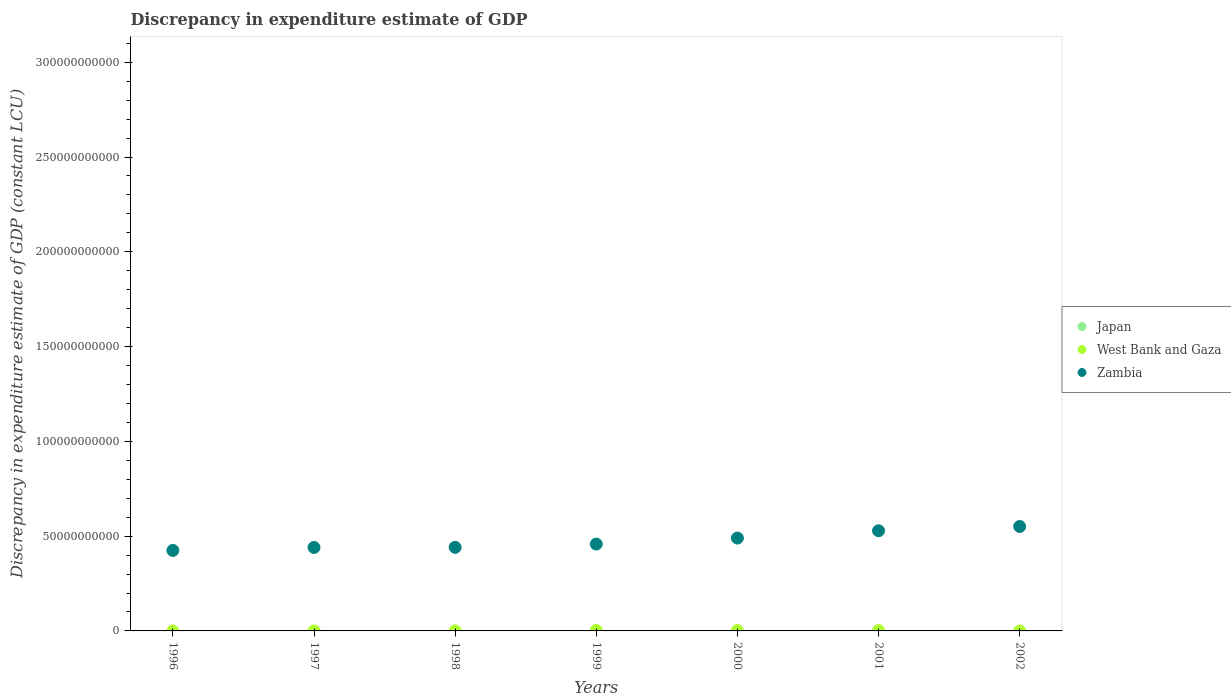How many different coloured dotlines are there?
Your answer should be compact. 2. Is the number of dotlines equal to the number of legend labels?
Your answer should be compact. No. Across all years, what is the maximum discrepancy in expenditure estimate of GDP in West Bank and Gaza?
Give a very brief answer. 2.63e+08. In which year was the discrepancy in expenditure estimate of GDP in Zambia maximum?
Give a very brief answer. 2002. What is the difference between the discrepancy in expenditure estimate of GDP in Zambia in 1999 and that in 2001?
Your answer should be compact. -7.03e+09. What is the difference between the discrepancy in expenditure estimate of GDP in Japan in 1997 and the discrepancy in expenditure estimate of GDP in Zambia in 2000?
Provide a succinct answer. -4.90e+1. What is the average discrepancy in expenditure estimate of GDP in Zambia per year?
Give a very brief answer. 4.76e+1. In the year 1999, what is the difference between the discrepancy in expenditure estimate of GDP in West Bank and Gaza and discrepancy in expenditure estimate of GDP in Zambia?
Make the answer very short. -4.55e+1. What is the ratio of the discrepancy in expenditure estimate of GDP in Zambia in 1997 to that in 1999?
Your answer should be compact. 0.96. Is the difference between the discrepancy in expenditure estimate of GDP in West Bank and Gaza in 1998 and 1999 greater than the difference between the discrepancy in expenditure estimate of GDP in Zambia in 1998 and 1999?
Keep it short and to the point. Yes. What is the difference between the highest and the second highest discrepancy in expenditure estimate of GDP in West Bank and Gaza?
Your answer should be compact. 3.36e+07. What is the difference between the highest and the lowest discrepancy in expenditure estimate of GDP in West Bank and Gaza?
Give a very brief answer. 2.63e+08. In how many years, is the discrepancy in expenditure estimate of GDP in Zambia greater than the average discrepancy in expenditure estimate of GDP in Zambia taken over all years?
Provide a short and direct response. 3. Is it the case that in every year, the sum of the discrepancy in expenditure estimate of GDP in Zambia and discrepancy in expenditure estimate of GDP in West Bank and Gaza  is greater than the discrepancy in expenditure estimate of GDP in Japan?
Keep it short and to the point. Yes. How many dotlines are there?
Make the answer very short. 2. How many years are there in the graph?
Your answer should be compact. 7. What is the difference between two consecutive major ticks on the Y-axis?
Provide a short and direct response. 5.00e+1. Are the values on the major ticks of Y-axis written in scientific E-notation?
Make the answer very short. No. Does the graph contain any zero values?
Offer a very short reply. Yes. How are the legend labels stacked?
Your answer should be very brief. Vertical. What is the title of the graph?
Provide a short and direct response. Discrepancy in expenditure estimate of GDP. What is the label or title of the Y-axis?
Your answer should be compact. Discrepancy in expenditure estimate of GDP (constant LCU). What is the Discrepancy in expenditure estimate of GDP (constant LCU) of Japan in 1996?
Offer a terse response. 0. What is the Discrepancy in expenditure estimate of GDP (constant LCU) of Zambia in 1996?
Your answer should be very brief. 4.25e+1. What is the Discrepancy in expenditure estimate of GDP (constant LCU) in Japan in 1997?
Keep it short and to the point. 0. What is the Discrepancy in expenditure estimate of GDP (constant LCU) in Zambia in 1997?
Offer a terse response. 4.40e+1. What is the Discrepancy in expenditure estimate of GDP (constant LCU) of West Bank and Gaza in 1998?
Your response must be concise. 6.65e+07. What is the Discrepancy in expenditure estimate of GDP (constant LCU) of Zambia in 1998?
Make the answer very short. 4.41e+1. What is the Discrepancy in expenditure estimate of GDP (constant LCU) of Japan in 1999?
Your answer should be compact. 0. What is the Discrepancy in expenditure estimate of GDP (constant LCU) of West Bank and Gaza in 1999?
Give a very brief answer. 2.63e+08. What is the Discrepancy in expenditure estimate of GDP (constant LCU) in Zambia in 1999?
Offer a terse response. 4.58e+1. What is the Discrepancy in expenditure estimate of GDP (constant LCU) of Japan in 2000?
Make the answer very short. 0. What is the Discrepancy in expenditure estimate of GDP (constant LCU) in West Bank and Gaza in 2000?
Ensure brevity in your answer.  2.30e+08. What is the Discrepancy in expenditure estimate of GDP (constant LCU) of Zambia in 2000?
Offer a terse response. 4.90e+1. What is the Discrepancy in expenditure estimate of GDP (constant LCU) in West Bank and Gaza in 2001?
Keep it short and to the point. 2.24e+08. What is the Discrepancy in expenditure estimate of GDP (constant LCU) of Zambia in 2001?
Offer a terse response. 5.28e+1. What is the Discrepancy in expenditure estimate of GDP (constant LCU) of Japan in 2002?
Give a very brief answer. 0. What is the Discrepancy in expenditure estimate of GDP (constant LCU) in West Bank and Gaza in 2002?
Give a very brief answer. 0. What is the Discrepancy in expenditure estimate of GDP (constant LCU) in Zambia in 2002?
Ensure brevity in your answer.  5.51e+1. Across all years, what is the maximum Discrepancy in expenditure estimate of GDP (constant LCU) of West Bank and Gaza?
Give a very brief answer. 2.63e+08. Across all years, what is the maximum Discrepancy in expenditure estimate of GDP (constant LCU) of Zambia?
Offer a very short reply. 5.51e+1. Across all years, what is the minimum Discrepancy in expenditure estimate of GDP (constant LCU) in West Bank and Gaza?
Keep it short and to the point. 0. Across all years, what is the minimum Discrepancy in expenditure estimate of GDP (constant LCU) in Zambia?
Offer a terse response. 4.25e+1. What is the total Discrepancy in expenditure estimate of GDP (constant LCU) of West Bank and Gaza in the graph?
Keep it short and to the point. 7.84e+08. What is the total Discrepancy in expenditure estimate of GDP (constant LCU) in Zambia in the graph?
Keep it short and to the point. 3.33e+11. What is the difference between the Discrepancy in expenditure estimate of GDP (constant LCU) in Zambia in 1996 and that in 1997?
Provide a short and direct response. -1.57e+09. What is the difference between the Discrepancy in expenditure estimate of GDP (constant LCU) in Zambia in 1996 and that in 1998?
Keep it short and to the point. -1.64e+09. What is the difference between the Discrepancy in expenditure estimate of GDP (constant LCU) in Zambia in 1996 and that in 1999?
Your response must be concise. -3.36e+09. What is the difference between the Discrepancy in expenditure estimate of GDP (constant LCU) in Zambia in 1996 and that in 2000?
Make the answer very short. -6.53e+09. What is the difference between the Discrepancy in expenditure estimate of GDP (constant LCU) in Zambia in 1996 and that in 2001?
Give a very brief answer. -1.04e+1. What is the difference between the Discrepancy in expenditure estimate of GDP (constant LCU) of Zambia in 1996 and that in 2002?
Give a very brief answer. -1.26e+1. What is the difference between the Discrepancy in expenditure estimate of GDP (constant LCU) of Zambia in 1997 and that in 1998?
Provide a succinct answer. -6.47e+07. What is the difference between the Discrepancy in expenditure estimate of GDP (constant LCU) in Zambia in 1997 and that in 1999?
Give a very brief answer. -1.78e+09. What is the difference between the Discrepancy in expenditure estimate of GDP (constant LCU) in Zambia in 1997 and that in 2000?
Keep it short and to the point. -4.95e+09. What is the difference between the Discrepancy in expenditure estimate of GDP (constant LCU) in Zambia in 1997 and that in 2001?
Offer a very short reply. -8.81e+09. What is the difference between the Discrepancy in expenditure estimate of GDP (constant LCU) of Zambia in 1997 and that in 2002?
Offer a very short reply. -1.11e+1. What is the difference between the Discrepancy in expenditure estimate of GDP (constant LCU) in West Bank and Gaza in 1998 and that in 1999?
Ensure brevity in your answer.  -1.97e+08. What is the difference between the Discrepancy in expenditure estimate of GDP (constant LCU) in Zambia in 1998 and that in 1999?
Your answer should be very brief. -1.72e+09. What is the difference between the Discrepancy in expenditure estimate of GDP (constant LCU) of West Bank and Gaza in 1998 and that in 2000?
Keep it short and to the point. -1.63e+08. What is the difference between the Discrepancy in expenditure estimate of GDP (constant LCU) of Zambia in 1998 and that in 2000?
Offer a very short reply. -4.89e+09. What is the difference between the Discrepancy in expenditure estimate of GDP (constant LCU) in West Bank and Gaza in 1998 and that in 2001?
Provide a succinct answer. -1.58e+08. What is the difference between the Discrepancy in expenditure estimate of GDP (constant LCU) in Zambia in 1998 and that in 2001?
Provide a short and direct response. -8.75e+09. What is the difference between the Discrepancy in expenditure estimate of GDP (constant LCU) in Zambia in 1998 and that in 2002?
Give a very brief answer. -1.10e+1. What is the difference between the Discrepancy in expenditure estimate of GDP (constant LCU) in West Bank and Gaza in 1999 and that in 2000?
Offer a terse response. 3.36e+07. What is the difference between the Discrepancy in expenditure estimate of GDP (constant LCU) of Zambia in 1999 and that in 2000?
Make the answer very short. -3.17e+09. What is the difference between the Discrepancy in expenditure estimate of GDP (constant LCU) in West Bank and Gaza in 1999 and that in 2001?
Offer a very short reply. 3.89e+07. What is the difference between the Discrepancy in expenditure estimate of GDP (constant LCU) in Zambia in 1999 and that in 2001?
Keep it short and to the point. -7.03e+09. What is the difference between the Discrepancy in expenditure estimate of GDP (constant LCU) in Zambia in 1999 and that in 2002?
Your response must be concise. -9.29e+09. What is the difference between the Discrepancy in expenditure estimate of GDP (constant LCU) in West Bank and Gaza in 2000 and that in 2001?
Offer a very short reply. 5.31e+06. What is the difference between the Discrepancy in expenditure estimate of GDP (constant LCU) of Zambia in 2000 and that in 2001?
Keep it short and to the point. -3.86e+09. What is the difference between the Discrepancy in expenditure estimate of GDP (constant LCU) in Zambia in 2000 and that in 2002?
Provide a succinct answer. -6.11e+09. What is the difference between the Discrepancy in expenditure estimate of GDP (constant LCU) in Zambia in 2001 and that in 2002?
Give a very brief answer. -2.26e+09. What is the difference between the Discrepancy in expenditure estimate of GDP (constant LCU) of West Bank and Gaza in 1998 and the Discrepancy in expenditure estimate of GDP (constant LCU) of Zambia in 1999?
Give a very brief answer. -4.57e+1. What is the difference between the Discrepancy in expenditure estimate of GDP (constant LCU) in West Bank and Gaza in 1998 and the Discrepancy in expenditure estimate of GDP (constant LCU) in Zambia in 2000?
Provide a short and direct response. -4.89e+1. What is the difference between the Discrepancy in expenditure estimate of GDP (constant LCU) in West Bank and Gaza in 1998 and the Discrepancy in expenditure estimate of GDP (constant LCU) in Zambia in 2001?
Provide a short and direct response. -5.28e+1. What is the difference between the Discrepancy in expenditure estimate of GDP (constant LCU) in West Bank and Gaza in 1998 and the Discrepancy in expenditure estimate of GDP (constant LCU) in Zambia in 2002?
Provide a short and direct response. -5.50e+1. What is the difference between the Discrepancy in expenditure estimate of GDP (constant LCU) of West Bank and Gaza in 1999 and the Discrepancy in expenditure estimate of GDP (constant LCU) of Zambia in 2000?
Make the answer very short. -4.87e+1. What is the difference between the Discrepancy in expenditure estimate of GDP (constant LCU) of West Bank and Gaza in 1999 and the Discrepancy in expenditure estimate of GDP (constant LCU) of Zambia in 2001?
Make the answer very short. -5.26e+1. What is the difference between the Discrepancy in expenditure estimate of GDP (constant LCU) in West Bank and Gaza in 1999 and the Discrepancy in expenditure estimate of GDP (constant LCU) in Zambia in 2002?
Ensure brevity in your answer.  -5.48e+1. What is the difference between the Discrepancy in expenditure estimate of GDP (constant LCU) of West Bank and Gaza in 2000 and the Discrepancy in expenditure estimate of GDP (constant LCU) of Zambia in 2001?
Give a very brief answer. -5.26e+1. What is the difference between the Discrepancy in expenditure estimate of GDP (constant LCU) in West Bank and Gaza in 2000 and the Discrepancy in expenditure estimate of GDP (constant LCU) in Zambia in 2002?
Your answer should be compact. -5.49e+1. What is the difference between the Discrepancy in expenditure estimate of GDP (constant LCU) in West Bank and Gaza in 2001 and the Discrepancy in expenditure estimate of GDP (constant LCU) in Zambia in 2002?
Offer a terse response. -5.49e+1. What is the average Discrepancy in expenditure estimate of GDP (constant LCU) of West Bank and Gaza per year?
Ensure brevity in your answer.  1.12e+08. What is the average Discrepancy in expenditure estimate of GDP (constant LCU) in Zambia per year?
Your answer should be very brief. 4.76e+1. In the year 1998, what is the difference between the Discrepancy in expenditure estimate of GDP (constant LCU) in West Bank and Gaza and Discrepancy in expenditure estimate of GDP (constant LCU) in Zambia?
Ensure brevity in your answer.  -4.40e+1. In the year 1999, what is the difference between the Discrepancy in expenditure estimate of GDP (constant LCU) in West Bank and Gaza and Discrepancy in expenditure estimate of GDP (constant LCU) in Zambia?
Ensure brevity in your answer.  -4.55e+1. In the year 2000, what is the difference between the Discrepancy in expenditure estimate of GDP (constant LCU) in West Bank and Gaza and Discrepancy in expenditure estimate of GDP (constant LCU) in Zambia?
Keep it short and to the point. -4.88e+1. In the year 2001, what is the difference between the Discrepancy in expenditure estimate of GDP (constant LCU) of West Bank and Gaza and Discrepancy in expenditure estimate of GDP (constant LCU) of Zambia?
Provide a short and direct response. -5.26e+1. What is the ratio of the Discrepancy in expenditure estimate of GDP (constant LCU) in Zambia in 1996 to that in 1997?
Offer a terse response. 0.96. What is the ratio of the Discrepancy in expenditure estimate of GDP (constant LCU) of Zambia in 1996 to that in 1998?
Keep it short and to the point. 0.96. What is the ratio of the Discrepancy in expenditure estimate of GDP (constant LCU) of Zambia in 1996 to that in 1999?
Offer a terse response. 0.93. What is the ratio of the Discrepancy in expenditure estimate of GDP (constant LCU) in Zambia in 1996 to that in 2000?
Give a very brief answer. 0.87. What is the ratio of the Discrepancy in expenditure estimate of GDP (constant LCU) in Zambia in 1996 to that in 2001?
Provide a succinct answer. 0.8. What is the ratio of the Discrepancy in expenditure estimate of GDP (constant LCU) in Zambia in 1996 to that in 2002?
Provide a short and direct response. 0.77. What is the ratio of the Discrepancy in expenditure estimate of GDP (constant LCU) of Zambia in 1997 to that in 1998?
Your answer should be very brief. 1. What is the ratio of the Discrepancy in expenditure estimate of GDP (constant LCU) of Zambia in 1997 to that in 1999?
Your answer should be compact. 0.96. What is the ratio of the Discrepancy in expenditure estimate of GDP (constant LCU) in Zambia in 1997 to that in 2000?
Ensure brevity in your answer.  0.9. What is the ratio of the Discrepancy in expenditure estimate of GDP (constant LCU) of Zambia in 1997 to that in 2001?
Offer a terse response. 0.83. What is the ratio of the Discrepancy in expenditure estimate of GDP (constant LCU) of Zambia in 1997 to that in 2002?
Your answer should be very brief. 0.8. What is the ratio of the Discrepancy in expenditure estimate of GDP (constant LCU) of West Bank and Gaza in 1998 to that in 1999?
Give a very brief answer. 0.25. What is the ratio of the Discrepancy in expenditure estimate of GDP (constant LCU) in Zambia in 1998 to that in 1999?
Ensure brevity in your answer.  0.96. What is the ratio of the Discrepancy in expenditure estimate of GDP (constant LCU) in West Bank and Gaza in 1998 to that in 2000?
Make the answer very short. 0.29. What is the ratio of the Discrepancy in expenditure estimate of GDP (constant LCU) in Zambia in 1998 to that in 2000?
Keep it short and to the point. 0.9. What is the ratio of the Discrepancy in expenditure estimate of GDP (constant LCU) in West Bank and Gaza in 1998 to that in 2001?
Make the answer very short. 0.3. What is the ratio of the Discrepancy in expenditure estimate of GDP (constant LCU) in Zambia in 1998 to that in 2001?
Keep it short and to the point. 0.83. What is the ratio of the Discrepancy in expenditure estimate of GDP (constant LCU) in Zambia in 1998 to that in 2002?
Your answer should be very brief. 0.8. What is the ratio of the Discrepancy in expenditure estimate of GDP (constant LCU) in West Bank and Gaza in 1999 to that in 2000?
Offer a very short reply. 1.15. What is the ratio of the Discrepancy in expenditure estimate of GDP (constant LCU) in Zambia in 1999 to that in 2000?
Provide a succinct answer. 0.94. What is the ratio of the Discrepancy in expenditure estimate of GDP (constant LCU) of West Bank and Gaza in 1999 to that in 2001?
Give a very brief answer. 1.17. What is the ratio of the Discrepancy in expenditure estimate of GDP (constant LCU) of Zambia in 1999 to that in 2001?
Ensure brevity in your answer.  0.87. What is the ratio of the Discrepancy in expenditure estimate of GDP (constant LCU) of Zambia in 1999 to that in 2002?
Ensure brevity in your answer.  0.83. What is the ratio of the Discrepancy in expenditure estimate of GDP (constant LCU) of West Bank and Gaza in 2000 to that in 2001?
Provide a short and direct response. 1.02. What is the ratio of the Discrepancy in expenditure estimate of GDP (constant LCU) of Zambia in 2000 to that in 2001?
Your answer should be compact. 0.93. What is the ratio of the Discrepancy in expenditure estimate of GDP (constant LCU) of Zambia in 2000 to that in 2002?
Make the answer very short. 0.89. What is the ratio of the Discrepancy in expenditure estimate of GDP (constant LCU) of Zambia in 2001 to that in 2002?
Your answer should be very brief. 0.96. What is the difference between the highest and the second highest Discrepancy in expenditure estimate of GDP (constant LCU) in West Bank and Gaza?
Make the answer very short. 3.36e+07. What is the difference between the highest and the second highest Discrepancy in expenditure estimate of GDP (constant LCU) in Zambia?
Your answer should be very brief. 2.26e+09. What is the difference between the highest and the lowest Discrepancy in expenditure estimate of GDP (constant LCU) in West Bank and Gaza?
Ensure brevity in your answer.  2.63e+08. What is the difference between the highest and the lowest Discrepancy in expenditure estimate of GDP (constant LCU) of Zambia?
Provide a short and direct response. 1.26e+1. 